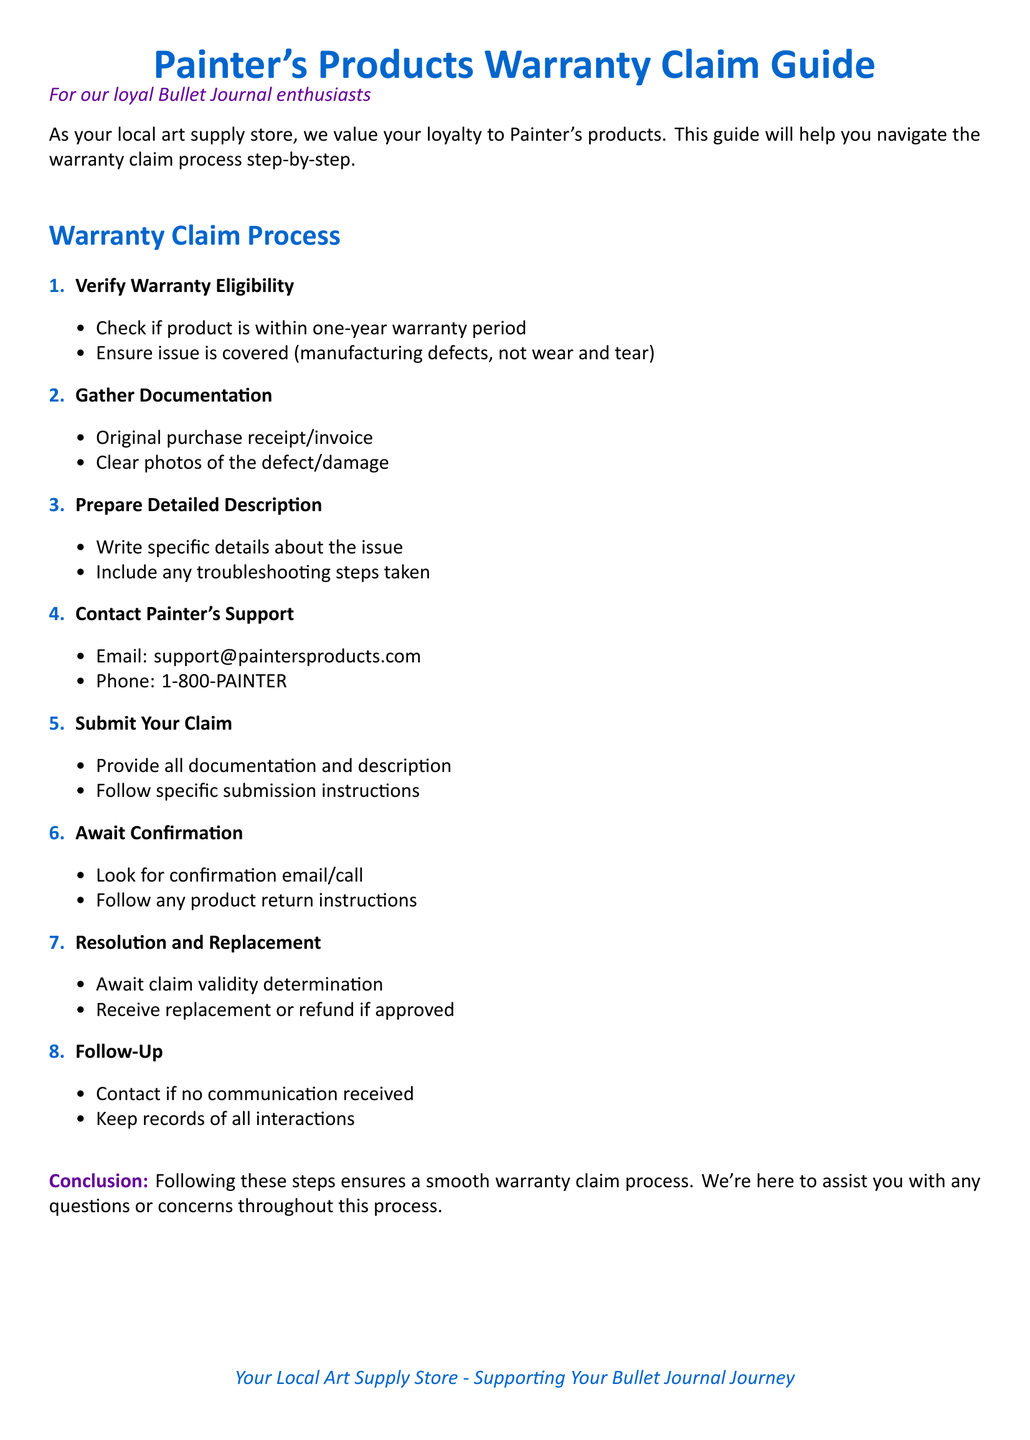What is the first step in the warranty claim process? The first step is to verify warranty eligibility.
Answer: Verify Warranty Eligibility What email should be used to contact Painter's support? The document states that the email for support is support@paintersproducts.com.
Answer: support@paintersproducts.com What is the phone number for Painter's support? The phone number provided is 1-800-PAINTER.
Answer: 1-800-PAINTER How many steps are there in the warranty claim process? The document lists eight steps in total for the warranty claim process.
Answer: Eight What documentation is needed according to the claim process? Required documentation includes the original purchase receipt/invoice and clear photos of the defect/damage.
Answer: Original purchase receipt/invoice and clear photos of the defect/damage What should you include in the detailed description for the claim? The detailed description should include specific details about the issue and any troubleshooting steps taken.
Answer: Specific details about the issue and troubleshooting steps taken What action should be taken if no communication is received after submission? The document suggests contacting support if no communication is received.
Answer: Contact support What is the final outcome of the warranty claim process? The final outcome can be a replacement or a refund if the claim is approved.
Answer: Replacement or refund 